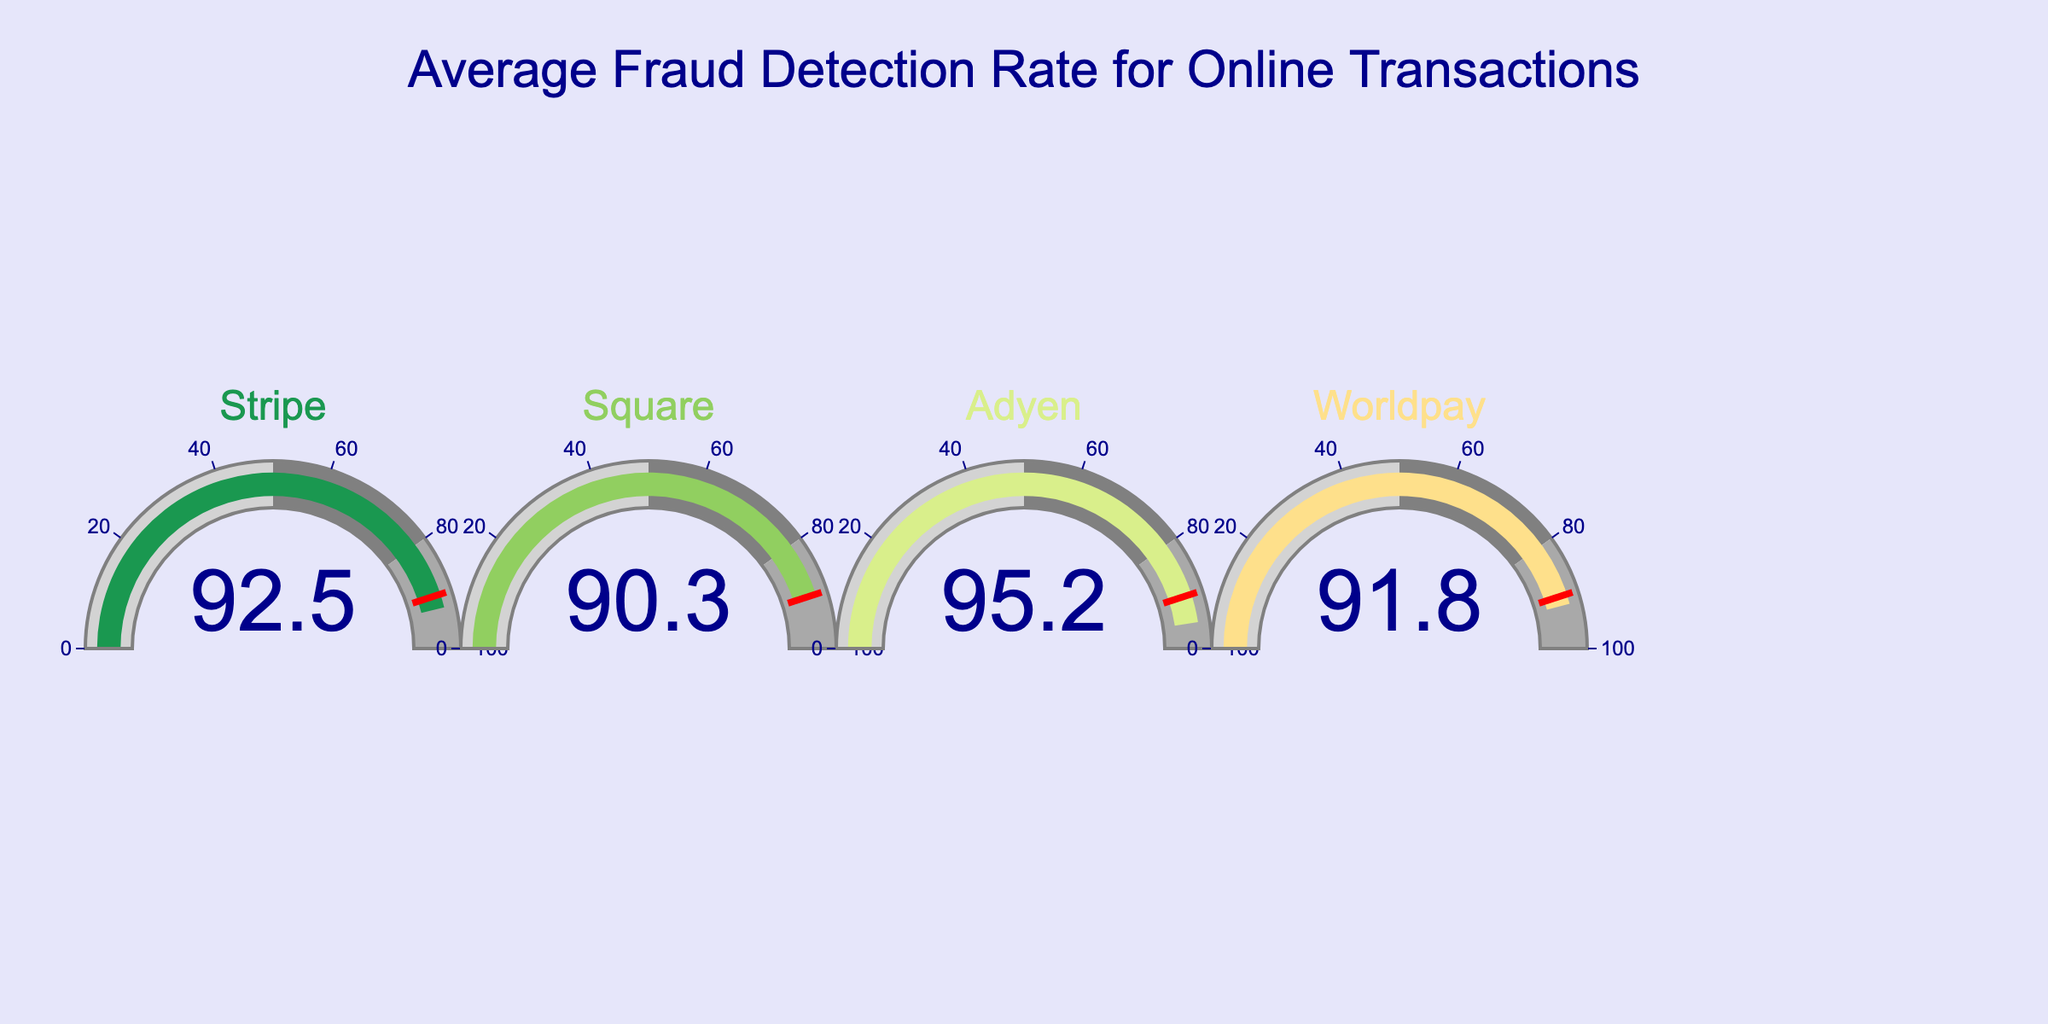How many companies are represented in the gauge chart? Count the number of separate gauge sections, each representing a different company.
Answer: 5 Which company has the highest fraud detection rate? Identify the company with the highest value displayed on the gauge.
Answer: Adyen What is the average fraud detection rate across all companies? Sum all the displayed fraud detection rates and divide by the number of companies: (94.7 + 92.5 + 90.3 + 95.2 + 91.8) / 5 = 464.5 / 5 = 92.9
Answer: 92.9 Which company's fraud detection rate is closest to the average rate? Determine the average rate (92.9) and find the company whose rate is closest to this value by comparing the differences.
Answer: Stripe How much higher is Adyen's fraud detection rate than Square's? Subtract Square's rate from Adyen's rate: 95.2 - 90.3
Answer: 4.9 Which companies have a fraud detection rate above 92%? Identify the companies with displayed rates greater than 92.
Answer: PayPal, Stripe, Adyen What's the range of fraud detection rates shown in the chart? Subtract the lowest rate from the highest rate: 95.2 - 90.3
Answer: 4.9 How do Worldpay and Stripe's fraud detection rates compare? Compare the displayed values of Worldpay and Stripe.
Answer: Worldpay's rate is lower than Stripe's Which company is closest to achieving 100% fraud detection rate? Identify the company with the highest rate displayed and see how close it is to 100%.
Answer: Adyen Is there a company that has a fraud detection rate below 90%? Check if any displayed value is less than 90%.
Answer: No 